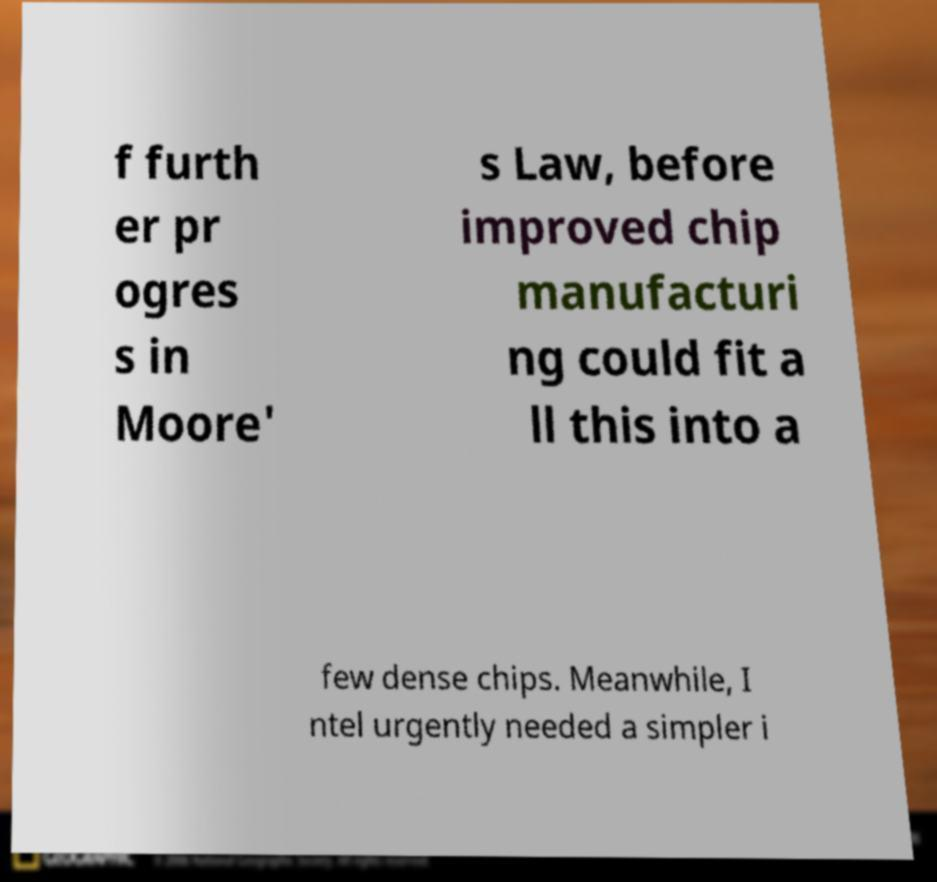Can you read and provide the text displayed in the image?This photo seems to have some interesting text. Can you extract and type it out for me? f furth er pr ogres s in Moore' s Law, before improved chip manufacturi ng could fit a ll this into a few dense chips. Meanwhile, I ntel urgently needed a simpler i 